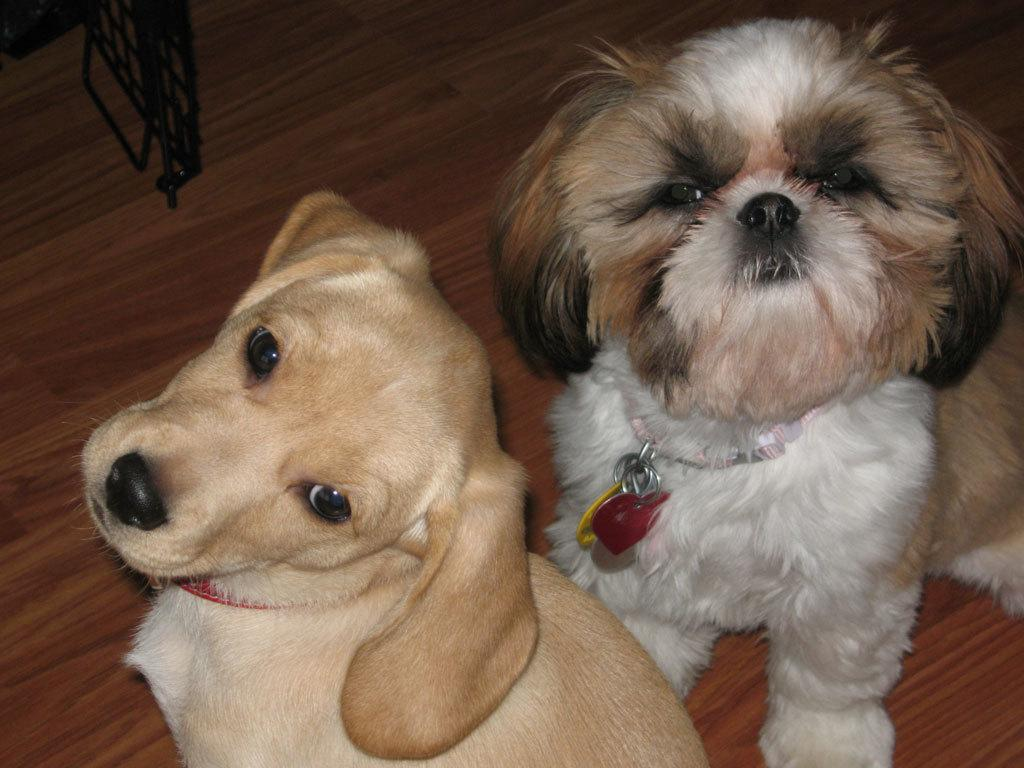How many dogs are in the image? There are two dogs in the image. What is the color of the dogs in the image? Both dogs are white in color. Do the dogs have any unique features or accessories? Yes, both dogs have belts. Can you tell me what spot the dogs are playing in the image? There is no specific spot mentioned in the image, and the dogs are not depicted as playing. 